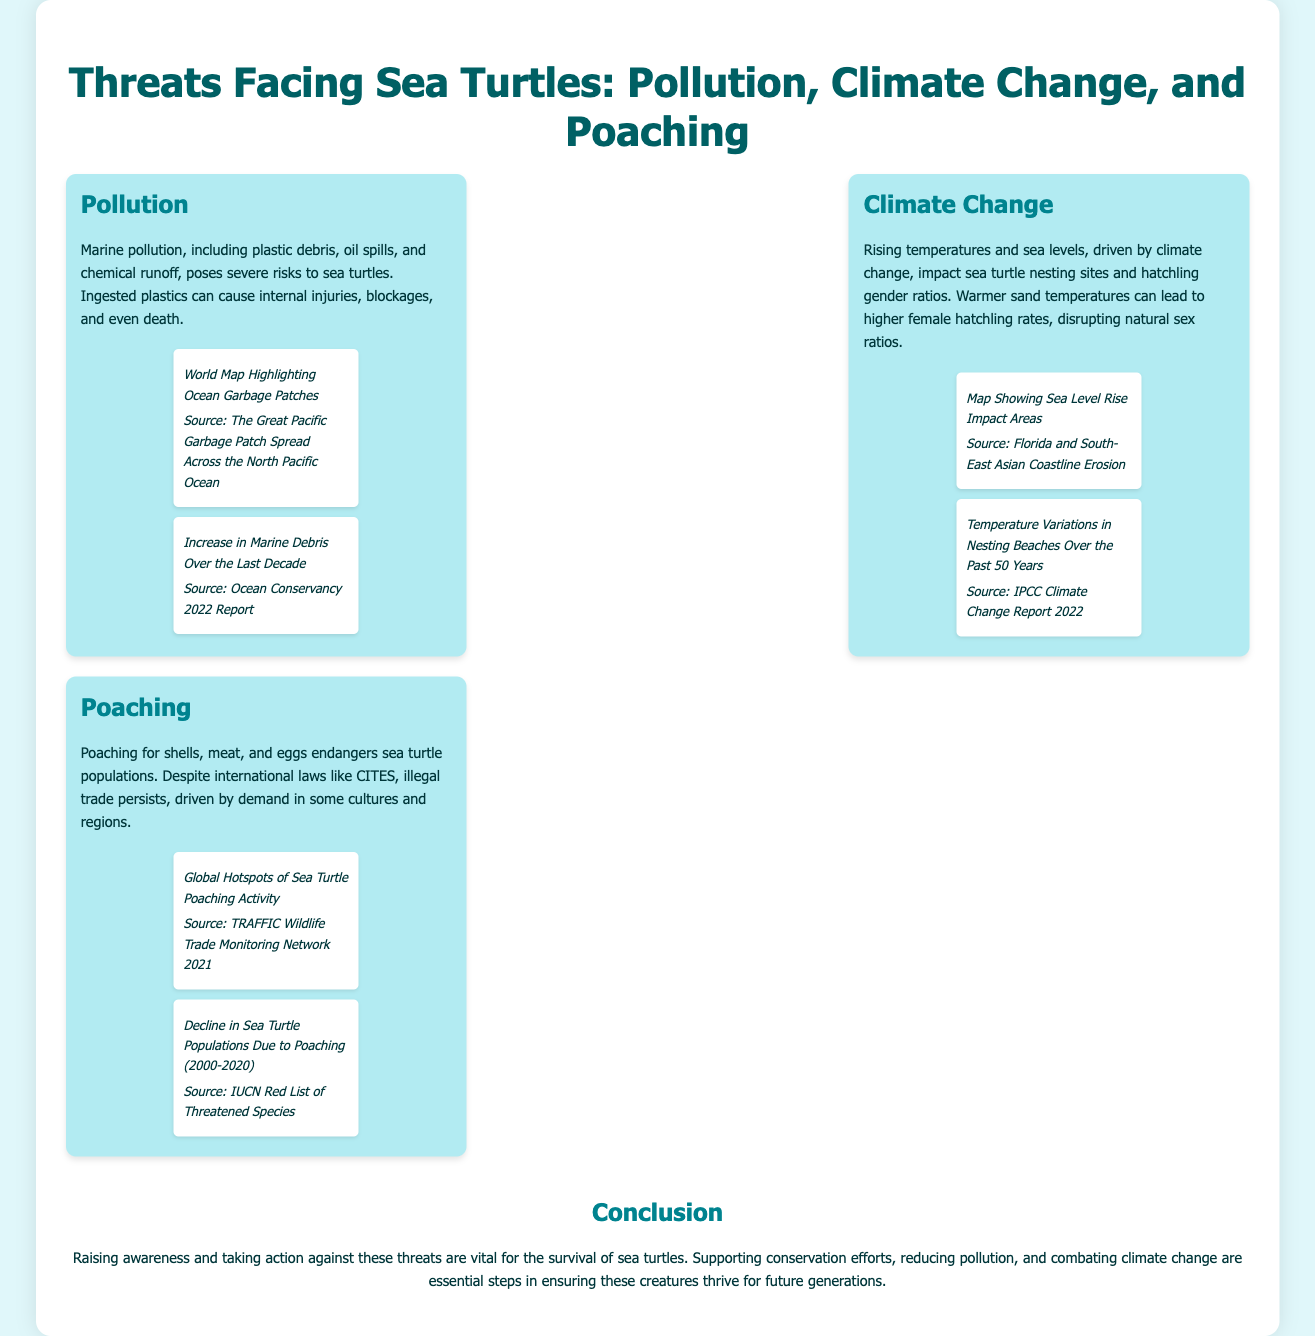What are the three main threats facing sea turtles? The document lists pollution, climate change, and poaching as the three main threats to sea turtles.
Answer: Pollution, climate change, and poaching What substance can cause internal injuries to sea turtles when ingested? The document mentions plastics as a substance that can cause internal injuries to sea turtles when ingested.
Answer: Plastics Which global phenomenon is affecting sea turtle nesting sites? The document indicates that climate change is impacting sea turtle nesting sites due to rising temperatures and sea levels.
Answer: Climate change What is the source of the map that shows ocean garbage patches? The document cites "The Great Pacific Garbage Patch Spread Across the North Pacific Ocean" as the source for the map highlighting ocean garbage patches.
Answer: The Great Pacific Garbage Patch Spread Across the North Pacific Ocean What organization produced the 2022 report on marine debris increases? The document mentions the Ocean Conservancy as the organization that produced the 2022 report on marine debris increases.
Answer: Ocean Conservancy What is a consequence of warmer sand temperatures for sea turtles? The document states that warmer sand temperatures can lead to higher female hatchling rates, disrupting natural sex ratios.
Answer: Higher female hatchling rates In what year does the poaching activity hotspot map originate from? The document indicates the source of the global hotspots of sea turtle poaching activity is from the year 2021.
Answer: 2021 Which significant action can help combat threats to sea turtles? The document concludes that raising awareness and supporting conservation efforts are vital actions to combat threats facing sea turtles.
Answer: Supporting conservation efforts What trend regarding sea turtle populations does the document highlight from 2000 to 2020? The document highlights a decline in sea turtle populations due to poaching from 2000 to 2020.
Answer: Decline in sea turtle populations 